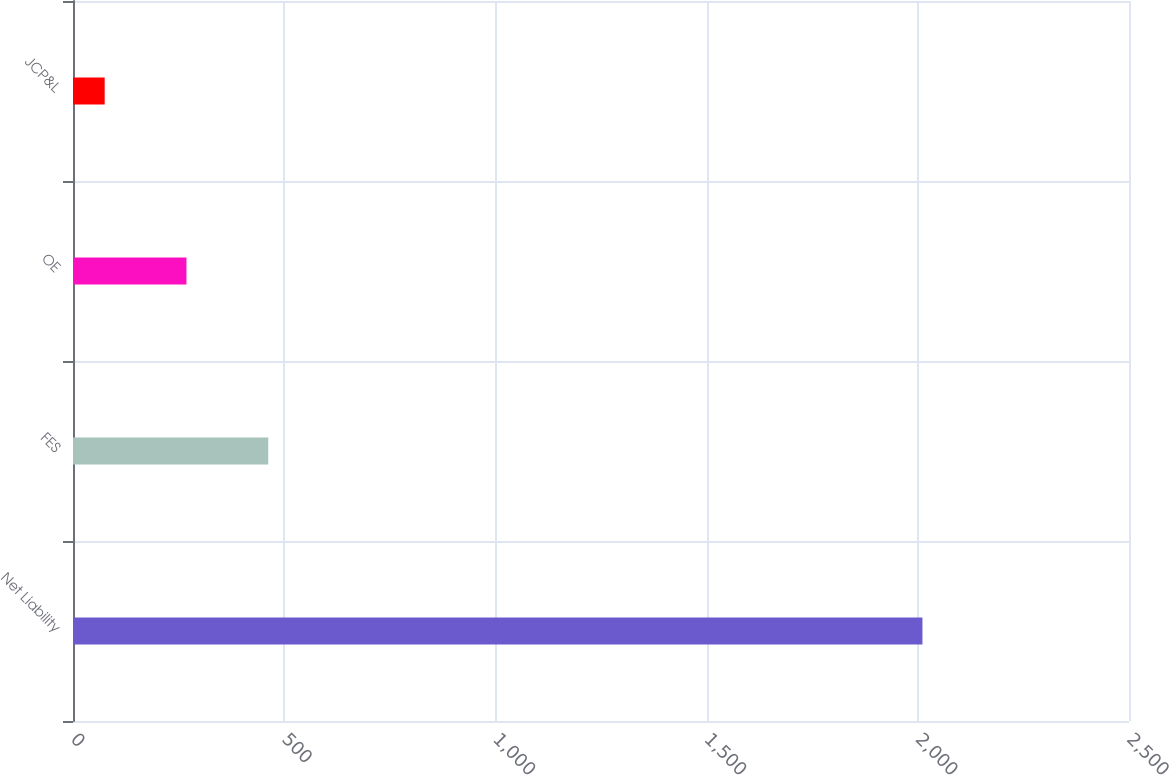Convert chart to OTSL. <chart><loc_0><loc_0><loc_500><loc_500><bar_chart><fcel>Net Liability<fcel>FES<fcel>OE<fcel>JCP&L<nl><fcel>2011<fcel>462.2<fcel>268.6<fcel>75<nl></chart> 